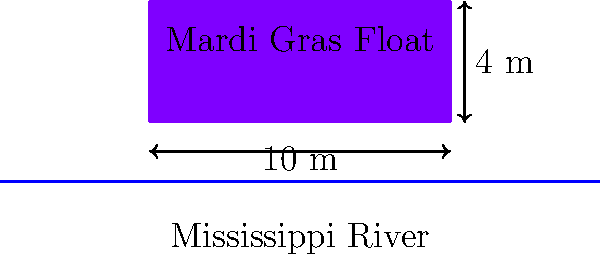A rectangular Mardi Gras float is being prepared for a parade along the Mississippi River. The float measures 10 m long, 5 m wide, and 4 m tall. It weighs 15,000 kg when empty. If the float is placed in the river, what is the maximum weight of riders and decorations that can be added before the float begins to sink? Assume the density of the river water is 1000 kg/m³. To solve this problem, we'll use Archimedes' principle and the concept of buoyancy. Let's break it down step by step:

1) First, calculate the volume of the float:
   $V = length \times width \times height = 10 \text{ m} \times 5 \text{ m} \times 4 \text{ m} = 200 \text{ m}^3$

2) The maximum volume of water displaced before sinking is the entire volume of the float: 200 m³.

3) Calculate the mass of water that would be displaced:
   $m_{water} = density \times volume = 1000 \text{ kg/m}^3 \times 200 \text{ m}^3 = 200,000 \text{ kg}$

4) This 200,000 kg is the maximum total mass the float can have before sinking.

5) The float already weighs 15,000 kg empty, so we subtract this from the total:
   $m_{additional} = 200,000 \text{ kg} - 15,000 \text{ kg} = 185,000 \text{ kg}$

6) Therefore, 185,000 kg is the maximum additional weight that can be added to the float before it begins to sink.
Answer: 185,000 kg 